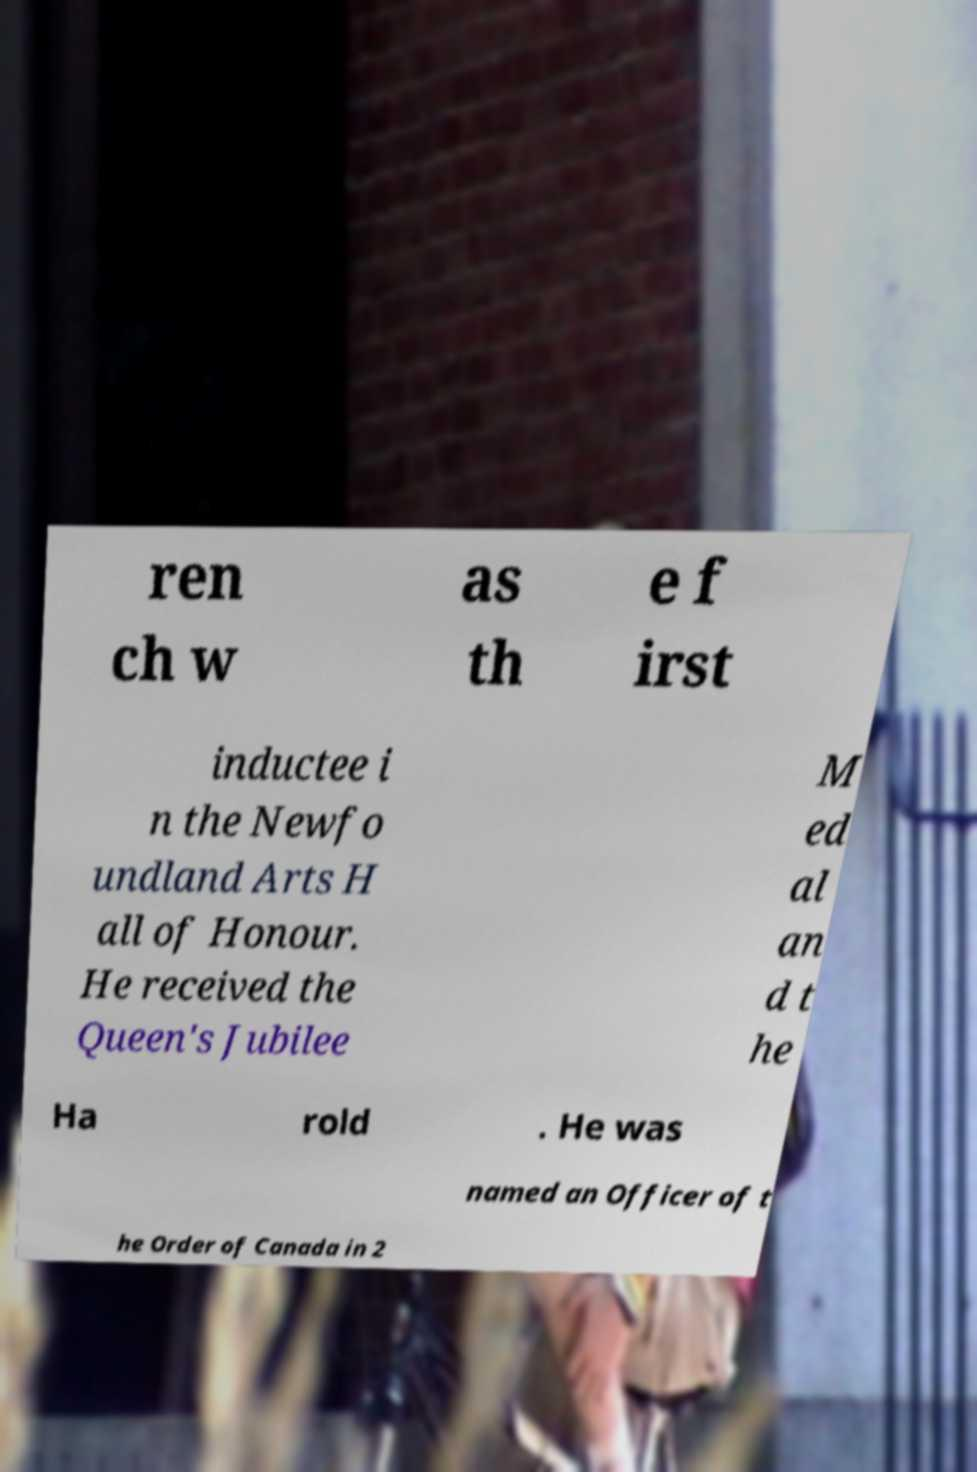Please read and relay the text visible in this image. What does it say? ren ch w as th e f irst inductee i n the Newfo undland Arts H all of Honour. He received the Queen's Jubilee M ed al an d t he Ha rold . He was named an Officer of t he Order of Canada in 2 